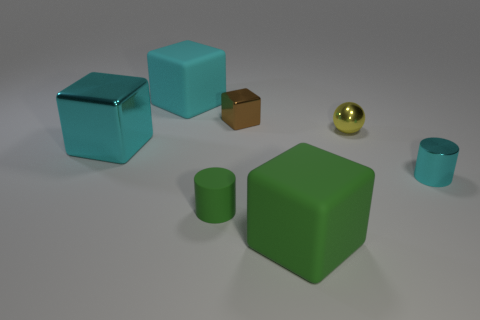Subtract all green rubber cubes. How many cubes are left? 3 Add 1 green cylinders. How many objects exist? 8 Subtract all gray spheres. How many cyan blocks are left? 2 Subtract 1 balls. How many balls are left? 0 Subtract all cyan cylinders. How many cylinders are left? 1 Subtract all balls. How many objects are left? 6 Add 3 big cyan objects. How many big cyan objects exist? 5 Subtract 0 gray blocks. How many objects are left? 7 Subtract all green cylinders. Subtract all brown balls. How many cylinders are left? 1 Subtract all cyan objects. Subtract all cyan shiny objects. How many objects are left? 2 